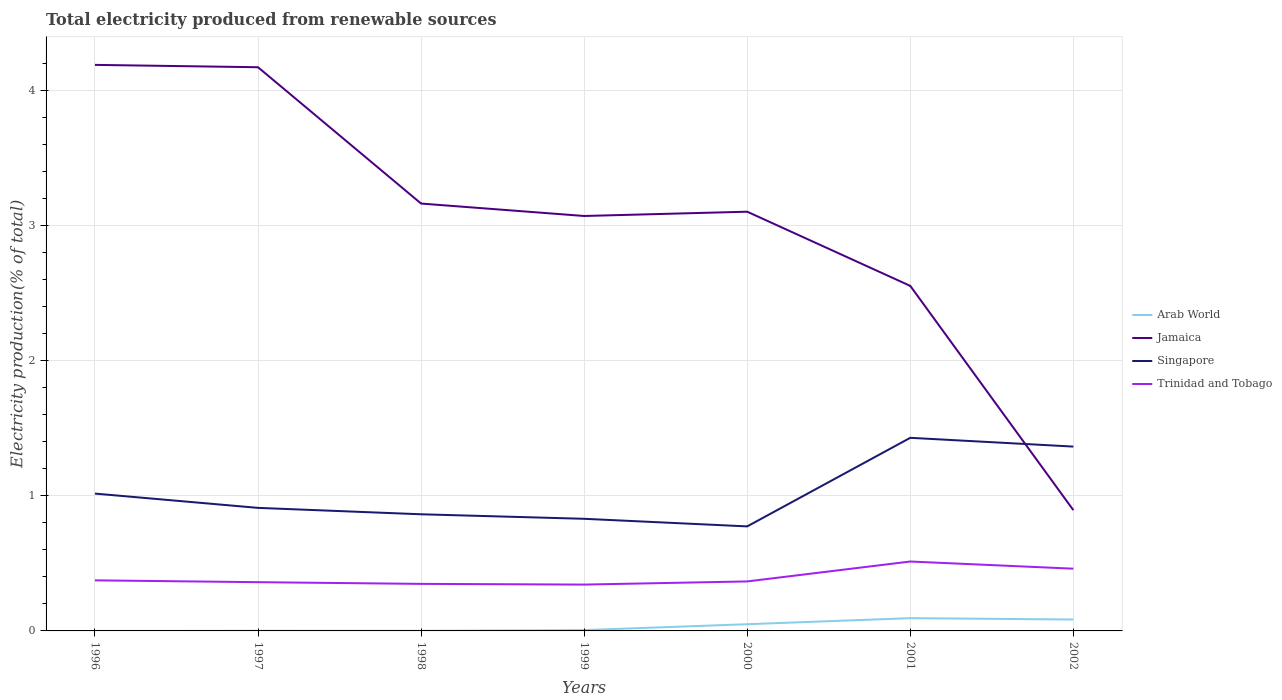How many different coloured lines are there?
Provide a succinct answer. 4. Does the line corresponding to Arab World intersect with the line corresponding to Jamaica?
Offer a terse response. No. Across all years, what is the maximum total electricity produced in Trinidad and Tobago?
Your answer should be very brief. 0.34. In which year was the total electricity produced in Trinidad and Tobago maximum?
Your response must be concise. 1999. What is the total total electricity produced in Singapore in the graph?
Give a very brief answer. 0.19. What is the difference between the highest and the second highest total electricity produced in Trinidad and Tobago?
Ensure brevity in your answer.  0.17. What is the difference between the highest and the lowest total electricity produced in Trinidad and Tobago?
Provide a short and direct response. 2. Is the total electricity produced in Trinidad and Tobago strictly greater than the total electricity produced in Jamaica over the years?
Keep it short and to the point. Yes. What is the difference between two consecutive major ticks on the Y-axis?
Give a very brief answer. 1. How are the legend labels stacked?
Ensure brevity in your answer.  Vertical. What is the title of the graph?
Give a very brief answer. Total electricity produced from renewable sources. Does "Sweden" appear as one of the legend labels in the graph?
Give a very brief answer. No. What is the Electricity production(% of total) in Arab World in 1996?
Offer a terse response. 0. What is the Electricity production(% of total) of Jamaica in 1996?
Offer a terse response. 4.19. What is the Electricity production(% of total) of Singapore in 1996?
Your answer should be very brief. 1.02. What is the Electricity production(% of total) of Trinidad and Tobago in 1996?
Your answer should be very brief. 0.37. What is the Electricity production(% of total) of Arab World in 1997?
Keep it short and to the point. 0. What is the Electricity production(% of total) in Jamaica in 1997?
Give a very brief answer. 4.17. What is the Electricity production(% of total) in Singapore in 1997?
Make the answer very short. 0.91. What is the Electricity production(% of total) in Trinidad and Tobago in 1997?
Give a very brief answer. 0.36. What is the Electricity production(% of total) of Arab World in 1998?
Provide a succinct answer. 0. What is the Electricity production(% of total) in Jamaica in 1998?
Your answer should be very brief. 3.16. What is the Electricity production(% of total) in Singapore in 1998?
Offer a very short reply. 0.86. What is the Electricity production(% of total) in Trinidad and Tobago in 1998?
Your response must be concise. 0.35. What is the Electricity production(% of total) in Arab World in 1999?
Ensure brevity in your answer.  0.01. What is the Electricity production(% of total) of Jamaica in 1999?
Offer a terse response. 3.07. What is the Electricity production(% of total) in Singapore in 1999?
Your response must be concise. 0.83. What is the Electricity production(% of total) in Trinidad and Tobago in 1999?
Provide a short and direct response. 0.34. What is the Electricity production(% of total) of Arab World in 2000?
Your answer should be compact. 0.05. What is the Electricity production(% of total) of Jamaica in 2000?
Provide a short and direct response. 3.1. What is the Electricity production(% of total) in Singapore in 2000?
Provide a succinct answer. 0.77. What is the Electricity production(% of total) of Trinidad and Tobago in 2000?
Give a very brief answer. 0.37. What is the Electricity production(% of total) in Arab World in 2001?
Your response must be concise. 0.09. What is the Electricity production(% of total) in Jamaica in 2001?
Offer a very short reply. 2.55. What is the Electricity production(% of total) in Singapore in 2001?
Offer a terse response. 1.43. What is the Electricity production(% of total) of Trinidad and Tobago in 2001?
Provide a succinct answer. 0.51. What is the Electricity production(% of total) in Arab World in 2002?
Make the answer very short. 0.08. What is the Electricity production(% of total) of Jamaica in 2002?
Your answer should be compact. 0.89. What is the Electricity production(% of total) in Singapore in 2002?
Your response must be concise. 1.36. What is the Electricity production(% of total) in Trinidad and Tobago in 2002?
Provide a succinct answer. 0.46. Across all years, what is the maximum Electricity production(% of total) in Arab World?
Offer a very short reply. 0.09. Across all years, what is the maximum Electricity production(% of total) in Jamaica?
Provide a short and direct response. 4.19. Across all years, what is the maximum Electricity production(% of total) in Singapore?
Your response must be concise. 1.43. Across all years, what is the maximum Electricity production(% of total) of Trinidad and Tobago?
Your response must be concise. 0.51. Across all years, what is the minimum Electricity production(% of total) of Arab World?
Offer a very short reply. 0. Across all years, what is the minimum Electricity production(% of total) in Jamaica?
Your answer should be compact. 0.89. Across all years, what is the minimum Electricity production(% of total) in Singapore?
Keep it short and to the point. 0.77. Across all years, what is the minimum Electricity production(% of total) in Trinidad and Tobago?
Your response must be concise. 0.34. What is the total Electricity production(% of total) in Arab World in the graph?
Offer a terse response. 0.24. What is the total Electricity production(% of total) of Jamaica in the graph?
Ensure brevity in your answer.  21.15. What is the total Electricity production(% of total) in Singapore in the graph?
Provide a short and direct response. 7.19. What is the total Electricity production(% of total) in Trinidad and Tobago in the graph?
Your response must be concise. 2.77. What is the difference between the Electricity production(% of total) in Arab World in 1996 and that in 1997?
Provide a short and direct response. -0. What is the difference between the Electricity production(% of total) in Jamaica in 1996 and that in 1997?
Offer a very short reply. 0.02. What is the difference between the Electricity production(% of total) in Singapore in 1996 and that in 1997?
Provide a succinct answer. 0.11. What is the difference between the Electricity production(% of total) in Trinidad and Tobago in 1996 and that in 1997?
Keep it short and to the point. 0.01. What is the difference between the Electricity production(% of total) of Arab World in 1996 and that in 1998?
Your answer should be very brief. -0. What is the difference between the Electricity production(% of total) in Jamaica in 1996 and that in 1998?
Offer a terse response. 1.03. What is the difference between the Electricity production(% of total) of Singapore in 1996 and that in 1998?
Give a very brief answer. 0.15. What is the difference between the Electricity production(% of total) in Trinidad and Tobago in 1996 and that in 1998?
Your response must be concise. 0.03. What is the difference between the Electricity production(% of total) of Arab World in 1996 and that in 1999?
Offer a very short reply. -0.01. What is the difference between the Electricity production(% of total) in Jamaica in 1996 and that in 1999?
Ensure brevity in your answer.  1.12. What is the difference between the Electricity production(% of total) of Singapore in 1996 and that in 1999?
Provide a succinct answer. 0.19. What is the difference between the Electricity production(% of total) in Trinidad and Tobago in 1996 and that in 1999?
Offer a terse response. 0.03. What is the difference between the Electricity production(% of total) in Arab World in 1996 and that in 2000?
Make the answer very short. -0.05. What is the difference between the Electricity production(% of total) in Jamaica in 1996 and that in 2000?
Give a very brief answer. 1.09. What is the difference between the Electricity production(% of total) of Singapore in 1996 and that in 2000?
Your answer should be very brief. 0.24. What is the difference between the Electricity production(% of total) in Trinidad and Tobago in 1996 and that in 2000?
Provide a short and direct response. 0.01. What is the difference between the Electricity production(% of total) of Arab World in 1996 and that in 2001?
Provide a short and direct response. -0.09. What is the difference between the Electricity production(% of total) in Jamaica in 1996 and that in 2001?
Your answer should be compact. 1.64. What is the difference between the Electricity production(% of total) in Singapore in 1996 and that in 2001?
Your answer should be compact. -0.41. What is the difference between the Electricity production(% of total) of Trinidad and Tobago in 1996 and that in 2001?
Make the answer very short. -0.14. What is the difference between the Electricity production(% of total) in Arab World in 1996 and that in 2002?
Make the answer very short. -0.08. What is the difference between the Electricity production(% of total) of Jamaica in 1996 and that in 2002?
Your answer should be compact. 3.3. What is the difference between the Electricity production(% of total) of Singapore in 1996 and that in 2002?
Offer a terse response. -0.35. What is the difference between the Electricity production(% of total) of Trinidad and Tobago in 1996 and that in 2002?
Your answer should be compact. -0.09. What is the difference between the Electricity production(% of total) in Arab World in 1997 and that in 1998?
Make the answer very short. 0. What is the difference between the Electricity production(% of total) of Jamaica in 1997 and that in 1998?
Keep it short and to the point. 1.01. What is the difference between the Electricity production(% of total) of Singapore in 1997 and that in 1998?
Your answer should be compact. 0.05. What is the difference between the Electricity production(% of total) of Trinidad and Tobago in 1997 and that in 1998?
Ensure brevity in your answer.  0.01. What is the difference between the Electricity production(% of total) in Arab World in 1997 and that in 1999?
Provide a short and direct response. -0.01. What is the difference between the Electricity production(% of total) in Jamaica in 1997 and that in 1999?
Ensure brevity in your answer.  1.1. What is the difference between the Electricity production(% of total) in Singapore in 1997 and that in 1999?
Provide a succinct answer. 0.08. What is the difference between the Electricity production(% of total) in Trinidad and Tobago in 1997 and that in 1999?
Your answer should be compact. 0.02. What is the difference between the Electricity production(% of total) of Arab World in 1997 and that in 2000?
Provide a succinct answer. -0.05. What is the difference between the Electricity production(% of total) of Jamaica in 1997 and that in 2000?
Provide a succinct answer. 1.07. What is the difference between the Electricity production(% of total) of Singapore in 1997 and that in 2000?
Your answer should be compact. 0.14. What is the difference between the Electricity production(% of total) in Trinidad and Tobago in 1997 and that in 2000?
Give a very brief answer. -0.01. What is the difference between the Electricity production(% of total) of Arab World in 1997 and that in 2001?
Make the answer very short. -0.09. What is the difference between the Electricity production(% of total) of Jamaica in 1997 and that in 2001?
Offer a terse response. 1.62. What is the difference between the Electricity production(% of total) of Singapore in 1997 and that in 2001?
Ensure brevity in your answer.  -0.52. What is the difference between the Electricity production(% of total) of Trinidad and Tobago in 1997 and that in 2001?
Make the answer very short. -0.15. What is the difference between the Electricity production(% of total) of Arab World in 1997 and that in 2002?
Keep it short and to the point. -0.08. What is the difference between the Electricity production(% of total) of Jamaica in 1997 and that in 2002?
Make the answer very short. 3.28. What is the difference between the Electricity production(% of total) in Singapore in 1997 and that in 2002?
Keep it short and to the point. -0.45. What is the difference between the Electricity production(% of total) in Trinidad and Tobago in 1997 and that in 2002?
Keep it short and to the point. -0.1. What is the difference between the Electricity production(% of total) in Arab World in 1998 and that in 1999?
Offer a very short reply. -0.01. What is the difference between the Electricity production(% of total) of Jamaica in 1998 and that in 1999?
Keep it short and to the point. 0.09. What is the difference between the Electricity production(% of total) of Singapore in 1998 and that in 1999?
Your response must be concise. 0.03. What is the difference between the Electricity production(% of total) in Trinidad and Tobago in 1998 and that in 1999?
Ensure brevity in your answer.  0.01. What is the difference between the Electricity production(% of total) in Arab World in 1998 and that in 2000?
Ensure brevity in your answer.  -0.05. What is the difference between the Electricity production(% of total) in Jamaica in 1998 and that in 2000?
Provide a short and direct response. 0.06. What is the difference between the Electricity production(% of total) of Singapore in 1998 and that in 2000?
Your answer should be very brief. 0.09. What is the difference between the Electricity production(% of total) of Trinidad and Tobago in 1998 and that in 2000?
Ensure brevity in your answer.  -0.02. What is the difference between the Electricity production(% of total) in Arab World in 1998 and that in 2001?
Your answer should be very brief. -0.09. What is the difference between the Electricity production(% of total) in Jamaica in 1998 and that in 2001?
Give a very brief answer. 0.61. What is the difference between the Electricity production(% of total) of Singapore in 1998 and that in 2001?
Give a very brief answer. -0.57. What is the difference between the Electricity production(% of total) in Trinidad and Tobago in 1998 and that in 2001?
Ensure brevity in your answer.  -0.17. What is the difference between the Electricity production(% of total) of Arab World in 1998 and that in 2002?
Your answer should be compact. -0.08. What is the difference between the Electricity production(% of total) in Jamaica in 1998 and that in 2002?
Offer a terse response. 2.27. What is the difference between the Electricity production(% of total) of Singapore in 1998 and that in 2002?
Your answer should be very brief. -0.5. What is the difference between the Electricity production(% of total) in Trinidad and Tobago in 1998 and that in 2002?
Give a very brief answer. -0.11. What is the difference between the Electricity production(% of total) of Arab World in 1999 and that in 2000?
Give a very brief answer. -0.04. What is the difference between the Electricity production(% of total) in Jamaica in 1999 and that in 2000?
Ensure brevity in your answer.  -0.03. What is the difference between the Electricity production(% of total) of Singapore in 1999 and that in 2000?
Offer a terse response. 0.06. What is the difference between the Electricity production(% of total) in Trinidad and Tobago in 1999 and that in 2000?
Keep it short and to the point. -0.02. What is the difference between the Electricity production(% of total) of Arab World in 1999 and that in 2001?
Offer a very short reply. -0.09. What is the difference between the Electricity production(% of total) in Jamaica in 1999 and that in 2001?
Your answer should be very brief. 0.52. What is the difference between the Electricity production(% of total) of Singapore in 1999 and that in 2001?
Your answer should be very brief. -0.6. What is the difference between the Electricity production(% of total) of Trinidad and Tobago in 1999 and that in 2001?
Provide a short and direct response. -0.17. What is the difference between the Electricity production(% of total) of Arab World in 1999 and that in 2002?
Give a very brief answer. -0.08. What is the difference between the Electricity production(% of total) in Jamaica in 1999 and that in 2002?
Your response must be concise. 2.18. What is the difference between the Electricity production(% of total) in Singapore in 1999 and that in 2002?
Keep it short and to the point. -0.53. What is the difference between the Electricity production(% of total) of Trinidad and Tobago in 1999 and that in 2002?
Give a very brief answer. -0.12. What is the difference between the Electricity production(% of total) of Arab World in 2000 and that in 2001?
Ensure brevity in your answer.  -0.04. What is the difference between the Electricity production(% of total) of Jamaica in 2000 and that in 2001?
Your answer should be compact. 0.55. What is the difference between the Electricity production(% of total) in Singapore in 2000 and that in 2001?
Offer a terse response. -0.66. What is the difference between the Electricity production(% of total) of Trinidad and Tobago in 2000 and that in 2001?
Offer a very short reply. -0.15. What is the difference between the Electricity production(% of total) of Arab World in 2000 and that in 2002?
Make the answer very short. -0.03. What is the difference between the Electricity production(% of total) of Jamaica in 2000 and that in 2002?
Give a very brief answer. 2.21. What is the difference between the Electricity production(% of total) in Singapore in 2000 and that in 2002?
Provide a succinct answer. -0.59. What is the difference between the Electricity production(% of total) of Trinidad and Tobago in 2000 and that in 2002?
Provide a short and direct response. -0.09. What is the difference between the Electricity production(% of total) of Arab World in 2001 and that in 2002?
Your answer should be compact. 0.01. What is the difference between the Electricity production(% of total) in Jamaica in 2001 and that in 2002?
Your answer should be compact. 1.66. What is the difference between the Electricity production(% of total) in Singapore in 2001 and that in 2002?
Ensure brevity in your answer.  0.07. What is the difference between the Electricity production(% of total) in Trinidad and Tobago in 2001 and that in 2002?
Your response must be concise. 0.05. What is the difference between the Electricity production(% of total) in Arab World in 1996 and the Electricity production(% of total) in Jamaica in 1997?
Offer a terse response. -4.17. What is the difference between the Electricity production(% of total) in Arab World in 1996 and the Electricity production(% of total) in Singapore in 1997?
Make the answer very short. -0.91. What is the difference between the Electricity production(% of total) of Arab World in 1996 and the Electricity production(% of total) of Trinidad and Tobago in 1997?
Your answer should be compact. -0.36. What is the difference between the Electricity production(% of total) of Jamaica in 1996 and the Electricity production(% of total) of Singapore in 1997?
Ensure brevity in your answer.  3.28. What is the difference between the Electricity production(% of total) in Jamaica in 1996 and the Electricity production(% of total) in Trinidad and Tobago in 1997?
Provide a succinct answer. 3.83. What is the difference between the Electricity production(% of total) in Singapore in 1996 and the Electricity production(% of total) in Trinidad and Tobago in 1997?
Keep it short and to the point. 0.66. What is the difference between the Electricity production(% of total) in Arab World in 1996 and the Electricity production(% of total) in Jamaica in 1998?
Provide a short and direct response. -3.16. What is the difference between the Electricity production(% of total) of Arab World in 1996 and the Electricity production(% of total) of Singapore in 1998?
Your answer should be compact. -0.86. What is the difference between the Electricity production(% of total) of Arab World in 1996 and the Electricity production(% of total) of Trinidad and Tobago in 1998?
Your answer should be compact. -0.35. What is the difference between the Electricity production(% of total) in Jamaica in 1996 and the Electricity production(% of total) in Singapore in 1998?
Make the answer very short. 3.33. What is the difference between the Electricity production(% of total) in Jamaica in 1996 and the Electricity production(% of total) in Trinidad and Tobago in 1998?
Keep it short and to the point. 3.84. What is the difference between the Electricity production(% of total) in Singapore in 1996 and the Electricity production(% of total) in Trinidad and Tobago in 1998?
Keep it short and to the point. 0.67. What is the difference between the Electricity production(% of total) of Arab World in 1996 and the Electricity production(% of total) of Jamaica in 1999?
Offer a terse response. -3.07. What is the difference between the Electricity production(% of total) in Arab World in 1996 and the Electricity production(% of total) in Singapore in 1999?
Make the answer very short. -0.83. What is the difference between the Electricity production(% of total) in Arab World in 1996 and the Electricity production(% of total) in Trinidad and Tobago in 1999?
Give a very brief answer. -0.34. What is the difference between the Electricity production(% of total) of Jamaica in 1996 and the Electricity production(% of total) of Singapore in 1999?
Your answer should be very brief. 3.36. What is the difference between the Electricity production(% of total) of Jamaica in 1996 and the Electricity production(% of total) of Trinidad and Tobago in 1999?
Give a very brief answer. 3.85. What is the difference between the Electricity production(% of total) of Singapore in 1996 and the Electricity production(% of total) of Trinidad and Tobago in 1999?
Provide a short and direct response. 0.67. What is the difference between the Electricity production(% of total) in Arab World in 1996 and the Electricity production(% of total) in Jamaica in 2000?
Give a very brief answer. -3.1. What is the difference between the Electricity production(% of total) in Arab World in 1996 and the Electricity production(% of total) in Singapore in 2000?
Give a very brief answer. -0.77. What is the difference between the Electricity production(% of total) in Arab World in 1996 and the Electricity production(% of total) in Trinidad and Tobago in 2000?
Your answer should be compact. -0.37. What is the difference between the Electricity production(% of total) of Jamaica in 1996 and the Electricity production(% of total) of Singapore in 2000?
Keep it short and to the point. 3.42. What is the difference between the Electricity production(% of total) in Jamaica in 1996 and the Electricity production(% of total) in Trinidad and Tobago in 2000?
Offer a terse response. 3.82. What is the difference between the Electricity production(% of total) of Singapore in 1996 and the Electricity production(% of total) of Trinidad and Tobago in 2000?
Your answer should be compact. 0.65. What is the difference between the Electricity production(% of total) of Arab World in 1996 and the Electricity production(% of total) of Jamaica in 2001?
Offer a terse response. -2.55. What is the difference between the Electricity production(% of total) of Arab World in 1996 and the Electricity production(% of total) of Singapore in 2001?
Offer a terse response. -1.43. What is the difference between the Electricity production(% of total) of Arab World in 1996 and the Electricity production(% of total) of Trinidad and Tobago in 2001?
Provide a succinct answer. -0.51. What is the difference between the Electricity production(% of total) of Jamaica in 1996 and the Electricity production(% of total) of Singapore in 2001?
Keep it short and to the point. 2.76. What is the difference between the Electricity production(% of total) in Jamaica in 1996 and the Electricity production(% of total) in Trinidad and Tobago in 2001?
Ensure brevity in your answer.  3.68. What is the difference between the Electricity production(% of total) in Singapore in 1996 and the Electricity production(% of total) in Trinidad and Tobago in 2001?
Provide a succinct answer. 0.5. What is the difference between the Electricity production(% of total) in Arab World in 1996 and the Electricity production(% of total) in Jamaica in 2002?
Your answer should be compact. -0.89. What is the difference between the Electricity production(% of total) of Arab World in 1996 and the Electricity production(% of total) of Singapore in 2002?
Your response must be concise. -1.36. What is the difference between the Electricity production(% of total) in Arab World in 1996 and the Electricity production(% of total) in Trinidad and Tobago in 2002?
Give a very brief answer. -0.46. What is the difference between the Electricity production(% of total) of Jamaica in 1996 and the Electricity production(% of total) of Singapore in 2002?
Give a very brief answer. 2.83. What is the difference between the Electricity production(% of total) in Jamaica in 1996 and the Electricity production(% of total) in Trinidad and Tobago in 2002?
Provide a short and direct response. 3.73. What is the difference between the Electricity production(% of total) in Singapore in 1996 and the Electricity production(% of total) in Trinidad and Tobago in 2002?
Ensure brevity in your answer.  0.56. What is the difference between the Electricity production(% of total) of Arab World in 1997 and the Electricity production(% of total) of Jamaica in 1998?
Make the answer very short. -3.16. What is the difference between the Electricity production(% of total) of Arab World in 1997 and the Electricity production(% of total) of Singapore in 1998?
Your response must be concise. -0.86. What is the difference between the Electricity production(% of total) of Arab World in 1997 and the Electricity production(% of total) of Trinidad and Tobago in 1998?
Offer a terse response. -0.35. What is the difference between the Electricity production(% of total) of Jamaica in 1997 and the Electricity production(% of total) of Singapore in 1998?
Offer a very short reply. 3.31. What is the difference between the Electricity production(% of total) of Jamaica in 1997 and the Electricity production(% of total) of Trinidad and Tobago in 1998?
Your answer should be very brief. 3.82. What is the difference between the Electricity production(% of total) of Singapore in 1997 and the Electricity production(% of total) of Trinidad and Tobago in 1998?
Ensure brevity in your answer.  0.56. What is the difference between the Electricity production(% of total) in Arab World in 1997 and the Electricity production(% of total) in Jamaica in 1999?
Offer a very short reply. -3.07. What is the difference between the Electricity production(% of total) in Arab World in 1997 and the Electricity production(% of total) in Singapore in 1999?
Your answer should be very brief. -0.83. What is the difference between the Electricity production(% of total) in Arab World in 1997 and the Electricity production(% of total) in Trinidad and Tobago in 1999?
Keep it short and to the point. -0.34. What is the difference between the Electricity production(% of total) in Jamaica in 1997 and the Electricity production(% of total) in Singapore in 1999?
Make the answer very short. 3.34. What is the difference between the Electricity production(% of total) of Jamaica in 1997 and the Electricity production(% of total) of Trinidad and Tobago in 1999?
Make the answer very short. 3.83. What is the difference between the Electricity production(% of total) of Singapore in 1997 and the Electricity production(% of total) of Trinidad and Tobago in 1999?
Offer a very short reply. 0.57. What is the difference between the Electricity production(% of total) in Arab World in 1997 and the Electricity production(% of total) in Jamaica in 2000?
Ensure brevity in your answer.  -3.1. What is the difference between the Electricity production(% of total) of Arab World in 1997 and the Electricity production(% of total) of Singapore in 2000?
Provide a succinct answer. -0.77. What is the difference between the Electricity production(% of total) in Arab World in 1997 and the Electricity production(% of total) in Trinidad and Tobago in 2000?
Your answer should be very brief. -0.37. What is the difference between the Electricity production(% of total) in Jamaica in 1997 and the Electricity production(% of total) in Singapore in 2000?
Your response must be concise. 3.4. What is the difference between the Electricity production(% of total) of Jamaica in 1997 and the Electricity production(% of total) of Trinidad and Tobago in 2000?
Your answer should be very brief. 3.81. What is the difference between the Electricity production(% of total) of Singapore in 1997 and the Electricity production(% of total) of Trinidad and Tobago in 2000?
Give a very brief answer. 0.54. What is the difference between the Electricity production(% of total) in Arab World in 1997 and the Electricity production(% of total) in Jamaica in 2001?
Offer a very short reply. -2.55. What is the difference between the Electricity production(% of total) in Arab World in 1997 and the Electricity production(% of total) in Singapore in 2001?
Provide a succinct answer. -1.43. What is the difference between the Electricity production(% of total) in Arab World in 1997 and the Electricity production(% of total) in Trinidad and Tobago in 2001?
Provide a short and direct response. -0.51. What is the difference between the Electricity production(% of total) in Jamaica in 1997 and the Electricity production(% of total) in Singapore in 2001?
Offer a terse response. 2.74. What is the difference between the Electricity production(% of total) in Jamaica in 1997 and the Electricity production(% of total) in Trinidad and Tobago in 2001?
Ensure brevity in your answer.  3.66. What is the difference between the Electricity production(% of total) of Singapore in 1997 and the Electricity production(% of total) of Trinidad and Tobago in 2001?
Ensure brevity in your answer.  0.4. What is the difference between the Electricity production(% of total) in Arab World in 1997 and the Electricity production(% of total) in Jamaica in 2002?
Keep it short and to the point. -0.89. What is the difference between the Electricity production(% of total) of Arab World in 1997 and the Electricity production(% of total) of Singapore in 2002?
Offer a terse response. -1.36. What is the difference between the Electricity production(% of total) in Arab World in 1997 and the Electricity production(% of total) in Trinidad and Tobago in 2002?
Offer a very short reply. -0.46. What is the difference between the Electricity production(% of total) of Jamaica in 1997 and the Electricity production(% of total) of Singapore in 2002?
Give a very brief answer. 2.81. What is the difference between the Electricity production(% of total) in Jamaica in 1997 and the Electricity production(% of total) in Trinidad and Tobago in 2002?
Your answer should be very brief. 3.71. What is the difference between the Electricity production(% of total) of Singapore in 1997 and the Electricity production(% of total) of Trinidad and Tobago in 2002?
Your answer should be compact. 0.45. What is the difference between the Electricity production(% of total) in Arab World in 1998 and the Electricity production(% of total) in Jamaica in 1999?
Your answer should be compact. -3.07. What is the difference between the Electricity production(% of total) of Arab World in 1998 and the Electricity production(% of total) of Singapore in 1999?
Your response must be concise. -0.83. What is the difference between the Electricity production(% of total) of Arab World in 1998 and the Electricity production(% of total) of Trinidad and Tobago in 1999?
Make the answer very short. -0.34. What is the difference between the Electricity production(% of total) of Jamaica in 1998 and the Electricity production(% of total) of Singapore in 1999?
Ensure brevity in your answer.  2.33. What is the difference between the Electricity production(% of total) of Jamaica in 1998 and the Electricity production(% of total) of Trinidad and Tobago in 1999?
Make the answer very short. 2.82. What is the difference between the Electricity production(% of total) in Singapore in 1998 and the Electricity production(% of total) in Trinidad and Tobago in 1999?
Provide a short and direct response. 0.52. What is the difference between the Electricity production(% of total) in Arab World in 1998 and the Electricity production(% of total) in Jamaica in 2000?
Offer a very short reply. -3.1. What is the difference between the Electricity production(% of total) of Arab World in 1998 and the Electricity production(% of total) of Singapore in 2000?
Keep it short and to the point. -0.77. What is the difference between the Electricity production(% of total) in Arab World in 1998 and the Electricity production(% of total) in Trinidad and Tobago in 2000?
Your response must be concise. -0.37. What is the difference between the Electricity production(% of total) in Jamaica in 1998 and the Electricity production(% of total) in Singapore in 2000?
Offer a very short reply. 2.39. What is the difference between the Electricity production(% of total) in Jamaica in 1998 and the Electricity production(% of total) in Trinidad and Tobago in 2000?
Your answer should be compact. 2.8. What is the difference between the Electricity production(% of total) in Singapore in 1998 and the Electricity production(% of total) in Trinidad and Tobago in 2000?
Offer a very short reply. 0.5. What is the difference between the Electricity production(% of total) of Arab World in 1998 and the Electricity production(% of total) of Jamaica in 2001?
Ensure brevity in your answer.  -2.55. What is the difference between the Electricity production(% of total) of Arab World in 1998 and the Electricity production(% of total) of Singapore in 2001?
Keep it short and to the point. -1.43. What is the difference between the Electricity production(% of total) in Arab World in 1998 and the Electricity production(% of total) in Trinidad and Tobago in 2001?
Offer a terse response. -0.51. What is the difference between the Electricity production(% of total) in Jamaica in 1998 and the Electricity production(% of total) in Singapore in 2001?
Make the answer very short. 1.73. What is the difference between the Electricity production(% of total) of Jamaica in 1998 and the Electricity production(% of total) of Trinidad and Tobago in 2001?
Ensure brevity in your answer.  2.65. What is the difference between the Electricity production(% of total) of Singapore in 1998 and the Electricity production(% of total) of Trinidad and Tobago in 2001?
Offer a terse response. 0.35. What is the difference between the Electricity production(% of total) of Arab World in 1998 and the Electricity production(% of total) of Jamaica in 2002?
Keep it short and to the point. -0.89. What is the difference between the Electricity production(% of total) of Arab World in 1998 and the Electricity production(% of total) of Singapore in 2002?
Your answer should be very brief. -1.36. What is the difference between the Electricity production(% of total) of Arab World in 1998 and the Electricity production(% of total) of Trinidad and Tobago in 2002?
Make the answer very short. -0.46. What is the difference between the Electricity production(% of total) in Jamaica in 1998 and the Electricity production(% of total) in Singapore in 2002?
Offer a very short reply. 1.8. What is the difference between the Electricity production(% of total) in Jamaica in 1998 and the Electricity production(% of total) in Trinidad and Tobago in 2002?
Ensure brevity in your answer.  2.7. What is the difference between the Electricity production(% of total) of Singapore in 1998 and the Electricity production(% of total) of Trinidad and Tobago in 2002?
Ensure brevity in your answer.  0.4. What is the difference between the Electricity production(% of total) in Arab World in 1999 and the Electricity production(% of total) in Jamaica in 2000?
Make the answer very short. -3.1. What is the difference between the Electricity production(% of total) of Arab World in 1999 and the Electricity production(% of total) of Singapore in 2000?
Provide a short and direct response. -0.77. What is the difference between the Electricity production(% of total) in Arab World in 1999 and the Electricity production(% of total) in Trinidad and Tobago in 2000?
Provide a succinct answer. -0.36. What is the difference between the Electricity production(% of total) in Jamaica in 1999 and the Electricity production(% of total) in Singapore in 2000?
Provide a short and direct response. 2.3. What is the difference between the Electricity production(% of total) in Jamaica in 1999 and the Electricity production(% of total) in Trinidad and Tobago in 2000?
Your response must be concise. 2.71. What is the difference between the Electricity production(% of total) of Singapore in 1999 and the Electricity production(% of total) of Trinidad and Tobago in 2000?
Give a very brief answer. 0.46. What is the difference between the Electricity production(% of total) of Arab World in 1999 and the Electricity production(% of total) of Jamaica in 2001?
Your answer should be very brief. -2.55. What is the difference between the Electricity production(% of total) in Arab World in 1999 and the Electricity production(% of total) in Singapore in 2001?
Give a very brief answer. -1.42. What is the difference between the Electricity production(% of total) of Arab World in 1999 and the Electricity production(% of total) of Trinidad and Tobago in 2001?
Offer a terse response. -0.51. What is the difference between the Electricity production(% of total) of Jamaica in 1999 and the Electricity production(% of total) of Singapore in 2001?
Give a very brief answer. 1.64. What is the difference between the Electricity production(% of total) in Jamaica in 1999 and the Electricity production(% of total) in Trinidad and Tobago in 2001?
Your answer should be very brief. 2.56. What is the difference between the Electricity production(% of total) of Singapore in 1999 and the Electricity production(% of total) of Trinidad and Tobago in 2001?
Your answer should be compact. 0.32. What is the difference between the Electricity production(% of total) in Arab World in 1999 and the Electricity production(% of total) in Jamaica in 2002?
Ensure brevity in your answer.  -0.89. What is the difference between the Electricity production(% of total) in Arab World in 1999 and the Electricity production(% of total) in Singapore in 2002?
Ensure brevity in your answer.  -1.36. What is the difference between the Electricity production(% of total) in Arab World in 1999 and the Electricity production(% of total) in Trinidad and Tobago in 2002?
Give a very brief answer. -0.45. What is the difference between the Electricity production(% of total) of Jamaica in 1999 and the Electricity production(% of total) of Singapore in 2002?
Your response must be concise. 1.71. What is the difference between the Electricity production(% of total) of Jamaica in 1999 and the Electricity production(% of total) of Trinidad and Tobago in 2002?
Provide a short and direct response. 2.61. What is the difference between the Electricity production(% of total) of Singapore in 1999 and the Electricity production(% of total) of Trinidad and Tobago in 2002?
Give a very brief answer. 0.37. What is the difference between the Electricity production(% of total) in Arab World in 2000 and the Electricity production(% of total) in Jamaica in 2001?
Your answer should be compact. -2.5. What is the difference between the Electricity production(% of total) in Arab World in 2000 and the Electricity production(% of total) in Singapore in 2001?
Ensure brevity in your answer.  -1.38. What is the difference between the Electricity production(% of total) of Arab World in 2000 and the Electricity production(% of total) of Trinidad and Tobago in 2001?
Provide a succinct answer. -0.46. What is the difference between the Electricity production(% of total) of Jamaica in 2000 and the Electricity production(% of total) of Singapore in 2001?
Your response must be concise. 1.67. What is the difference between the Electricity production(% of total) in Jamaica in 2000 and the Electricity production(% of total) in Trinidad and Tobago in 2001?
Your answer should be compact. 2.59. What is the difference between the Electricity production(% of total) in Singapore in 2000 and the Electricity production(% of total) in Trinidad and Tobago in 2001?
Your response must be concise. 0.26. What is the difference between the Electricity production(% of total) in Arab World in 2000 and the Electricity production(% of total) in Jamaica in 2002?
Your answer should be very brief. -0.84. What is the difference between the Electricity production(% of total) of Arab World in 2000 and the Electricity production(% of total) of Singapore in 2002?
Your answer should be very brief. -1.31. What is the difference between the Electricity production(% of total) of Arab World in 2000 and the Electricity production(% of total) of Trinidad and Tobago in 2002?
Your response must be concise. -0.41. What is the difference between the Electricity production(% of total) of Jamaica in 2000 and the Electricity production(% of total) of Singapore in 2002?
Provide a succinct answer. 1.74. What is the difference between the Electricity production(% of total) in Jamaica in 2000 and the Electricity production(% of total) in Trinidad and Tobago in 2002?
Provide a short and direct response. 2.64. What is the difference between the Electricity production(% of total) in Singapore in 2000 and the Electricity production(% of total) in Trinidad and Tobago in 2002?
Your answer should be very brief. 0.31. What is the difference between the Electricity production(% of total) in Arab World in 2001 and the Electricity production(% of total) in Jamaica in 2002?
Make the answer very short. -0.8. What is the difference between the Electricity production(% of total) in Arab World in 2001 and the Electricity production(% of total) in Singapore in 2002?
Provide a succinct answer. -1.27. What is the difference between the Electricity production(% of total) of Arab World in 2001 and the Electricity production(% of total) of Trinidad and Tobago in 2002?
Provide a succinct answer. -0.37. What is the difference between the Electricity production(% of total) of Jamaica in 2001 and the Electricity production(% of total) of Singapore in 2002?
Offer a terse response. 1.19. What is the difference between the Electricity production(% of total) in Jamaica in 2001 and the Electricity production(% of total) in Trinidad and Tobago in 2002?
Ensure brevity in your answer.  2.09. What is the difference between the Electricity production(% of total) of Singapore in 2001 and the Electricity production(% of total) of Trinidad and Tobago in 2002?
Your response must be concise. 0.97. What is the average Electricity production(% of total) in Arab World per year?
Make the answer very short. 0.03. What is the average Electricity production(% of total) of Jamaica per year?
Give a very brief answer. 3.02. What is the average Electricity production(% of total) in Singapore per year?
Offer a terse response. 1.03. What is the average Electricity production(% of total) in Trinidad and Tobago per year?
Your response must be concise. 0.4. In the year 1996, what is the difference between the Electricity production(% of total) of Arab World and Electricity production(% of total) of Jamaica?
Give a very brief answer. -4.19. In the year 1996, what is the difference between the Electricity production(% of total) of Arab World and Electricity production(% of total) of Singapore?
Give a very brief answer. -1.02. In the year 1996, what is the difference between the Electricity production(% of total) of Arab World and Electricity production(% of total) of Trinidad and Tobago?
Your answer should be compact. -0.37. In the year 1996, what is the difference between the Electricity production(% of total) in Jamaica and Electricity production(% of total) in Singapore?
Your answer should be very brief. 3.17. In the year 1996, what is the difference between the Electricity production(% of total) of Jamaica and Electricity production(% of total) of Trinidad and Tobago?
Your response must be concise. 3.82. In the year 1996, what is the difference between the Electricity production(% of total) in Singapore and Electricity production(% of total) in Trinidad and Tobago?
Provide a succinct answer. 0.64. In the year 1997, what is the difference between the Electricity production(% of total) in Arab World and Electricity production(% of total) in Jamaica?
Give a very brief answer. -4.17. In the year 1997, what is the difference between the Electricity production(% of total) in Arab World and Electricity production(% of total) in Singapore?
Offer a terse response. -0.91. In the year 1997, what is the difference between the Electricity production(% of total) of Arab World and Electricity production(% of total) of Trinidad and Tobago?
Keep it short and to the point. -0.36. In the year 1997, what is the difference between the Electricity production(% of total) in Jamaica and Electricity production(% of total) in Singapore?
Your response must be concise. 3.26. In the year 1997, what is the difference between the Electricity production(% of total) in Jamaica and Electricity production(% of total) in Trinidad and Tobago?
Ensure brevity in your answer.  3.81. In the year 1997, what is the difference between the Electricity production(% of total) of Singapore and Electricity production(% of total) of Trinidad and Tobago?
Your answer should be very brief. 0.55. In the year 1998, what is the difference between the Electricity production(% of total) of Arab World and Electricity production(% of total) of Jamaica?
Provide a succinct answer. -3.16. In the year 1998, what is the difference between the Electricity production(% of total) in Arab World and Electricity production(% of total) in Singapore?
Make the answer very short. -0.86. In the year 1998, what is the difference between the Electricity production(% of total) in Arab World and Electricity production(% of total) in Trinidad and Tobago?
Keep it short and to the point. -0.35. In the year 1998, what is the difference between the Electricity production(% of total) in Jamaica and Electricity production(% of total) in Singapore?
Provide a short and direct response. 2.3. In the year 1998, what is the difference between the Electricity production(% of total) of Jamaica and Electricity production(% of total) of Trinidad and Tobago?
Offer a very short reply. 2.82. In the year 1998, what is the difference between the Electricity production(% of total) of Singapore and Electricity production(% of total) of Trinidad and Tobago?
Your answer should be compact. 0.52. In the year 1999, what is the difference between the Electricity production(% of total) in Arab World and Electricity production(% of total) in Jamaica?
Make the answer very short. -3.07. In the year 1999, what is the difference between the Electricity production(% of total) of Arab World and Electricity production(% of total) of Singapore?
Provide a short and direct response. -0.82. In the year 1999, what is the difference between the Electricity production(% of total) in Arab World and Electricity production(% of total) in Trinidad and Tobago?
Your response must be concise. -0.34. In the year 1999, what is the difference between the Electricity production(% of total) in Jamaica and Electricity production(% of total) in Singapore?
Your answer should be very brief. 2.24. In the year 1999, what is the difference between the Electricity production(% of total) in Jamaica and Electricity production(% of total) in Trinidad and Tobago?
Give a very brief answer. 2.73. In the year 1999, what is the difference between the Electricity production(% of total) of Singapore and Electricity production(% of total) of Trinidad and Tobago?
Your response must be concise. 0.49. In the year 2000, what is the difference between the Electricity production(% of total) of Arab World and Electricity production(% of total) of Jamaica?
Offer a terse response. -3.05. In the year 2000, what is the difference between the Electricity production(% of total) of Arab World and Electricity production(% of total) of Singapore?
Your answer should be very brief. -0.72. In the year 2000, what is the difference between the Electricity production(% of total) of Arab World and Electricity production(% of total) of Trinidad and Tobago?
Give a very brief answer. -0.32. In the year 2000, what is the difference between the Electricity production(% of total) in Jamaica and Electricity production(% of total) in Singapore?
Give a very brief answer. 2.33. In the year 2000, what is the difference between the Electricity production(% of total) in Jamaica and Electricity production(% of total) in Trinidad and Tobago?
Offer a very short reply. 2.74. In the year 2000, what is the difference between the Electricity production(% of total) in Singapore and Electricity production(% of total) in Trinidad and Tobago?
Offer a terse response. 0.41. In the year 2001, what is the difference between the Electricity production(% of total) in Arab World and Electricity production(% of total) in Jamaica?
Ensure brevity in your answer.  -2.46. In the year 2001, what is the difference between the Electricity production(% of total) in Arab World and Electricity production(% of total) in Singapore?
Offer a terse response. -1.33. In the year 2001, what is the difference between the Electricity production(% of total) in Arab World and Electricity production(% of total) in Trinidad and Tobago?
Your answer should be compact. -0.42. In the year 2001, what is the difference between the Electricity production(% of total) of Jamaica and Electricity production(% of total) of Singapore?
Offer a very short reply. 1.12. In the year 2001, what is the difference between the Electricity production(% of total) in Jamaica and Electricity production(% of total) in Trinidad and Tobago?
Give a very brief answer. 2.04. In the year 2001, what is the difference between the Electricity production(% of total) of Singapore and Electricity production(% of total) of Trinidad and Tobago?
Offer a terse response. 0.92. In the year 2002, what is the difference between the Electricity production(% of total) of Arab World and Electricity production(% of total) of Jamaica?
Provide a succinct answer. -0.81. In the year 2002, what is the difference between the Electricity production(% of total) in Arab World and Electricity production(% of total) in Singapore?
Ensure brevity in your answer.  -1.28. In the year 2002, what is the difference between the Electricity production(% of total) of Arab World and Electricity production(% of total) of Trinidad and Tobago?
Keep it short and to the point. -0.38. In the year 2002, what is the difference between the Electricity production(% of total) in Jamaica and Electricity production(% of total) in Singapore?
Offer a terse response. -0.47. In the year 2002, what is the difference between the Electricity production(% of total) of Jamaica and Electricity production(% of total) of Trinidad and Tobago?
Offer a terse response. 0.43. In the year 2002, what is the difference between the Electricity production(% of total) in Singapore and Electricity production(% of total) in Trinidad and Tobago?
Provide a short and direct response. 0.9. What is the ratio of the Electricity production(% of total) of Arab World in 1996 to that in 1997?
Offer a terse response. 0.35. What is the ratio of the Electricity production(% of total) in Singapore in 1996 to that in 1997?
Your response must be concise. 1.12. What is the ratio of the Electricity production(% of total) in Trinidad and Tobago in 1996 to that in 1997?
Provide a succinct answer. 1.04. What is the ratio of the Electricity production(% of total) in Arab World in 1996 to that in 1998?
Ensure brevity in your answer.  0.38. What is the ratio of the Electricity production(% of total) of Jamaica in 1996 to that in 1998?
Offer a terse response. 1.32. What is the ratio of the Electricity production(% of total) in Singapore in 1996 to that in 1998?
Provide a succinct answer. 1.18. What is the ratio of the Electricity production(% of total) of Trinidad and Tobago in 1996 to that in 1998?
Your answer should be compact. 1.08. What is the ratio of the Electricity production(% of total) of Arab World in 1996 to that in 1999?
Keep it short and to the point. 0.04. What is the ratio of the Electricity production(% of total) in Jamaica in 1996 to that in 1999?
Make the answer very short. 1.36. What is the ratio of the Electricity production(% of total) in Singapore in 1996 to that in 1999?
Give a very brief answer. 1.22. What is the ratio of the Electricity production(% of total) of Trinidad and Tobago in 1996 to that in 1999?
Your response must be concise. 1.09. What is the ratio of the Electricity production(% of total) in Arab World in 1996 to that in 2000?
Give a very brief answer. 0.01. What is the ratio of the Electricity production(% of total) in Jamaica in 1996 to that in 2000?
Offer a very short reply. 1.35. What is the ratio of the Electricity production(% of total) of Singapore in 1996 to that in 2000?
Give a very brief answer. 1.31. What is the ratio of the Electricity production(% of total) in Trinidad and Tobago in 1996 to that in 2000?
Your response must be concise. 1.02. What is the ratio of the Electricity production(% of total) in Arab World in 1996 to that in 2001?
Offer a terse response. 0. What is the ratio of the Electricity production(% of total) in Jamaica in 1996 to that in 2001?
Keep it short and to the point. 1.64. What is the ratio of the Electricity production(% of total) in Singapore in 1996 to that in 2001?
Provide a short and direct response. 0.71. What is the ratio of the Electricity production(% of total) of Trinidad and Tobago in 1996 to that in 2001?
Provide a short and direct response. 0.73. What is the ratio of the Electricity production(% of total) in Arab World in 1996 to that in 2002?
Offer a terse response. 0. What is the ratio of the Electricity production(% of total) of Jamaica in 1996 to that in 2002?
Offer a very short reply. 4.69. What is the ratio of the Electricity production(% of total) in Singapore in 1996 to that in 2002?
Provide a succinct answer. 0.74. What is the ratio of the Electricity production(% of total) of Trinidad and Tobago in 1996 to that in 2002?
Offer a terse response. 0.81. What is the ratio of the Electricity production(% of total) of Arab World in 1997 to that in 1998?
Your answer should be compact. 1.08. What is the ratio of the Electricity production(% of total) of Jamaica in 1997 to that in 1998?
Your answer should be compact. 1.32. What is the ratio of the Electricity production(% of total) in Singapore in 1997 to that in 1998?
Provide a succinct answer. 1.05. What is the ratio of the Electricity production(% of total) of Trinidad and Tobago in 1997 to that in 1998?
Keep it short and to the point. 1.04. What is the ratio of the Electricity production(% of total) of Arab World in 1997 to that in 1999?
Ensure brevity in your answer.  0.13. What is the ratio of the Electricity production(% of total) in Jamaica in 1997 to that in 1999?
Your answer should be very brief. 1.36. What is the ratio of the Electricity production(% of total) of Singapore in 1997 to that in 1999?
Your response must be concise. 1.1. What is the ratio of the Electricity production(% of total) of Trinidad and Tobago in 1997 to that in 1999?
Your answer should be very brief. 1.05. What is the ratio of the Electricity production(% of total) of Arab World in 1997 to that in 2000?
Keep it short and to the point. 0.02. What is the ratio of the Electricity production(% of total) of Jamaica in 1997 to that in 2000?
Your answer should be compact. 1.34. What is the ratio of the Electricity production(% of total) of Singapore in 1997 to that in 2000?
Your answer should be very brief. 1.18. What is the ratio of the Electricity production(% of total) of Arab World in 1997 to that in 2001?
Ensure brevity in your answer.  0.01. What is the ratio of the Electricity production(% of total) in Jamaica in 1997 to that in 2001?
Keep it short and to the point. 1.63. What is the ratio of the Electricity production(% of total) in Singapore in 1997 to that in 2001?
Your answer should be compact. 0.64. What is the ratio of the Electricity production(% of total) in Trinidad and Tobago in 1997 to that in 2001?
Keep it short and to the point. 0.7. What is the ratio of the Electricity production(% of total) in Arab World in 1997 to that in 2002?
Offer a very short reply. 0.01. What is the ratio of the Electricity production(% of total) of Jamaica in 1997 to that in 2002?
Ensure brevity in your answer.  4.67. What is the ratio of the Electricity production(% of total) in Singapore in 1997 to that in 2002?
Give a very brief answer. 0.67. What is the ratio of the Electricity production(% of total) in Trinidad and Tobago in 1997 to that in 2002?
Give a very brief answer. 0.78. What is the ratio of the Electricity production(% of total) of Arab World in 1998 to that in 1999?
Your response must be concise. 0.12. What is the ratio of the Electricity production(% of total) in Jamaica in 1998 to that in 1999?
Provide a succinct answer. 1.03. What is the ratio of the Electricity production(% of total) in Singapore in 1998 to that in 1999?
Give a very brief answer. 1.04. What is the ratio of the Electricity production(% of total) in Trinidad and Tobago in 1998 to that in 1999?
Provide a short and direct response. 1.02. What is the ratio of the Electricity production(% of total) of Arab World in 1998 to that in 2000?
Give a very brief answer. 0.01. What is the ratio of the Electricity production(% of total) in Jamaica in 1998 to that in 2000?
Your response must be concise. 1.02. What is the ratio of the Electricity production(% of total) of Singapore in 1998 to that in 2000?
Provide a succinct answer. 1.12. What is the ratio of the Electricity production(% of total) in Trinidad and Tobago in 1998 to that in 2000?
Give a very brief answer. 0.95. What is the ratio of the Electricity production(% of total) of Arab World in 1998 to that in 2001?
Offer a terse response. 0.01. What is the ratio of the Electricity production(% of total) in Jamaica in 1998 to that in 2001?
Keep it short and to the point. 1.24. What is the ratio of the Electricity production(% of total) of Singapore in 1998 to that in 2001?
Offer a terse response. 0.6. What is the ratio of the Electricity production(% of total) of Trinidad and Tobago in 1998 to that in 2001?
Offer a terse response. 0.68. What is the ratio of the Electricity production(% of total) in Arab World in 1998 to that in 2002?
Your answer should be very brief. 0.01. What is the ratio of the Electricity production(% of total) of Jamaica in 1998 to that in 2002?
Offer a terse response. 3.54. What is the ratio of the Electricity production(% of total) of Singapore in 1998 to that in 2002?
Give a very brief answer. 0.63. What is the ratio of the Electricity production(% of total) of Trinidad and Tobago in 1998 to that in 2002?
Keep it short and to the point. 0.76. What is the ratio of the Electricity production(% of total) of Arab World in 1999 to that in 2000?
Provide a short and direct response. 0.13. What is the ratio of the Electricity production(% of total) in Jamaica in 1999 to that in 2000?
Offer a terse response. 0.99. What is the ratio of the Electricity production(% of total) of Singapore in 1999 to that in 2000?
Your response must be concise. 1.07. What is the ratio of the Electricity production(% of total) in Trinidad and Tobago in 1999 to that in 2000?
Provide a short and direct response. 0.94. What is the ratio of the Electricity production(% of total) in Arab World in 1999 to that in 2001?
Provide a short and direct response. 0.07. What is the ratio of the Electricity production(% of total) of Jamaica in 1999 to that in 2001?
Offer a terse response. 1.2. What is the ratio of the Electricity production(% of total) in Singapore in 1999 to that in 2001?
Offer a terse response. 0.58. What is the ratio of the Electricity production(% of total) of Trinidad and Tobago in 1999 to that in 2001?
Your answer should be very brief. 0.67. What is the ratio of the Electricity production(% of total) in Arab World in 1999 to that in 2002?
Provide a succinct answer. 0.07. What is the ratio of the Electricity production(% of total) of Jamaica in 1999 to that in 2002?
Provide a succinct answer. 3.44. What is the ratio of the Electricity production(% of total) of Singapore in 1999 to that in 2002?
Provide a succinct answer. 0.61. What is the ratio of the Electricity production(% of total) in Trinidad and Tobago in 1999 to that in 2002?
Give a very brief answer. 0.74. What is the ratio of the Electricity production(% of total) in Arab World in 2000 to that in 2001?
Offer a very short reply. 0.52. What is the ratio of the Electricity production(% of total) in Jamaica in 2000 to that in 2001?
Provide a short and direct response. 1.22. What is the ratio of the Electricity production(% of total) in Singapore in 2000 to that in 2001?
Offer a terse response. 0.54. What is the ratio of the Electricity production(% of total) of Trinidad and Tobago in 2000 to that in 2001?
Provide a succinct answer. 0.71. What is the ratio of the Electricity production(% of total) of Arab World in 2000 to that in 2002?
Provide a short and direct response. 0.59. What is the ratio of the Electricity production(% of total) in Jamaica in 2000 to that in 2002?
Make the answer very short. 3.47. What is the ratio of the Electricity production(% of total) in Singapore in 2000 to that in 2002?
Make the answer very short. 0.57. What is the ratio of the Electricity production(% of total) in Trinidad and Tobago in 2000 to that in 2002?
Offer a very short reply. 0.8. What is the ratio of the Electricity production(% of total) of Arab World in 2001 to that in 2002?
Your response must be concise. 1.12. What is the ratio of the Electricity production(% of total) of Jamaica in 2001 to that in 2002?
Keep it short and to the point. 2.86. What is the ratio of the Electricity production(% of total) in Singapore in 2001 to that in 2002?
Offer a terse response. 1.05. What is the ratio of the Electricity production(% of total) in Trinidad and Tobago in 2001 to that in 2002?
Offer a very short reply. 1.12. What is the difference between the highest and the second highest Electricity production(% of total) of Arab World?
Make the answer very short. 0.01. What is the difference between the highest and the second highest Electricity production(% of total) of Jamaica?
Provide a succinct answer. 0.02. What is the difference between the highest and the second highest Electricity production(% of total) of Singapore?
Provide a short and direct response. 0.07. What is the difference between the highest and the second highest Electricity production(% of total) in Trinidad and Tobago?
Make the answer very short. 0.05. What is the difference between the highest and the lowest Electricity production(% of total) of Arab World?
Keep it short and to the point. 0.09. What is the difference between the highest and the lowest Electricity production(% of total) of Jamaica?
Offer a very short reply. 3.3. What is the difference between the highest and the lowest Electricity production(% of total) in Singapore?
Your answer should be very brief. 0.66. What is the difference between the highest and the lowest Electricity production(% of total) of Trinidad and Tobago?
Ensure brevity in your answer.  0.17. 